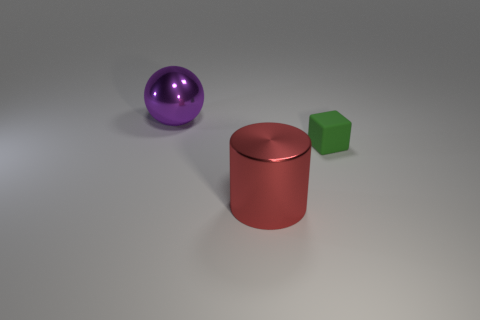Add 2 big cyan metal balls. How many objects exist? 5 Subtract all spheres. How many objects are left? 2 Subtract all small objects. Subtract all red objects. How many objects are left? 1 Add 3 cylinders. How many cylinders are left? 4 Add 2 purple cubes. How many purple cubes exist? 2 Subtract 0 yellow cylinders. How many objects are left? 3 